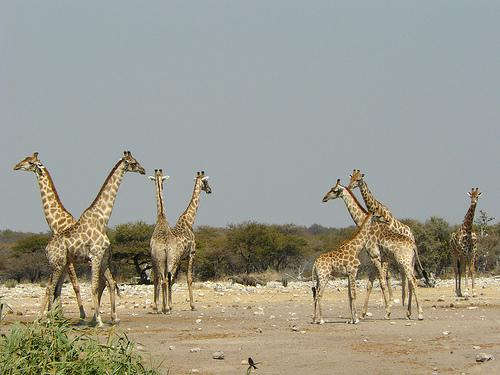What objects or features can be found near the giraffes in the image? A row of trees, a row of rocks, a patch of grass, a bird, and wild green foliage can be found near the giraffes in the image. Identify the main elements present in the scene and provide a brief description. The image shows a group of giraffes in a field with trees and rocks, a patch of grass, and a sky with no clouds. There is also a bird perched on the ground and green foliage around. What kind of landscape can be seen in the image, and how many giraffes are there? The landscape is a natural scenery with field, trees, and rocks, and there is a herd of eight giraffes. 